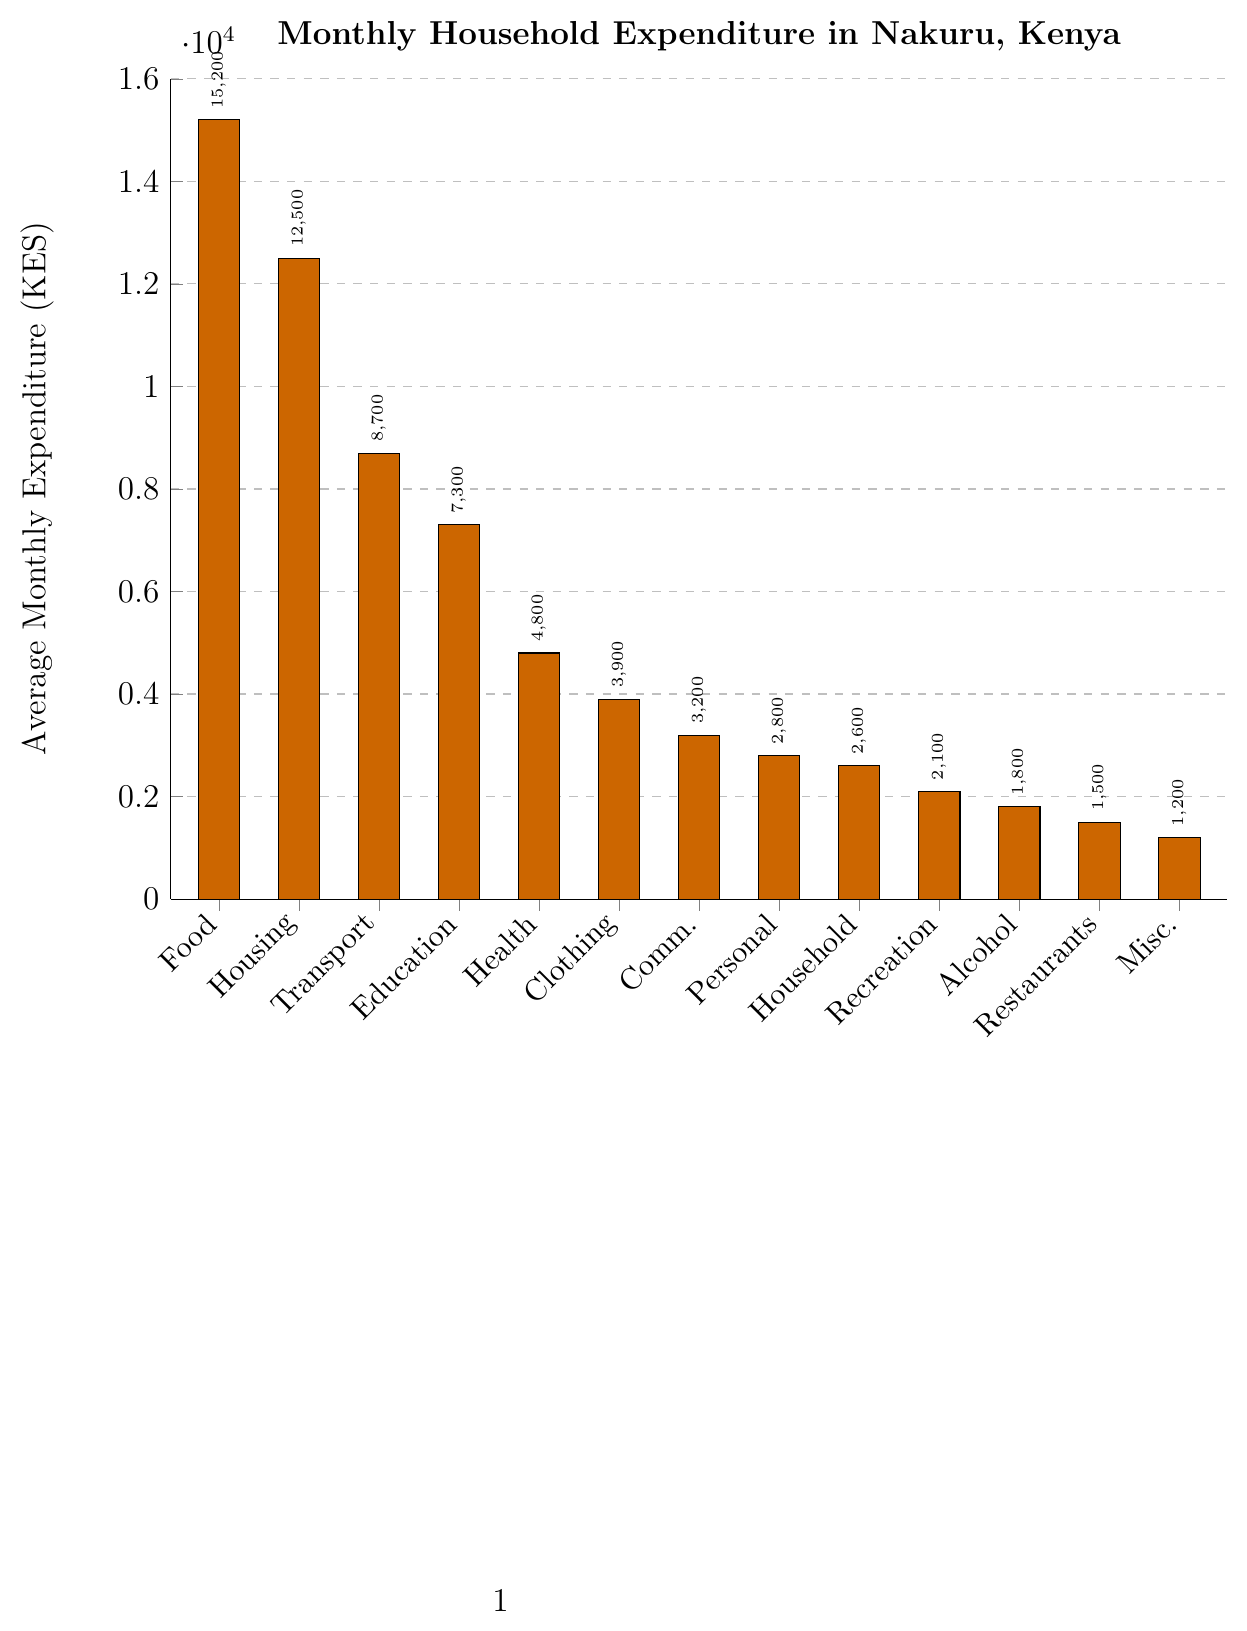Which category has the highest average monthly expenditure? The bar chart displays the height of each bar relative to the expenditure. The tallest bar, labeled "Food," represents the highest expenditure.
Answer: Food and non-alcoholic beverages Which category has the lowest average monthly expenditure? The shortest bar in the chart represents the lowest expenditure. The shortest bar is labeled "Misc."
Answer: Miscellaneous goods and services How much more do residents spend on Housing and utilities compared to Health? To find the difference in expenditures, subtract the expenditure for Health from the expenditure for Housing and utilities. That is 12500 - 4800.
Answer: 7700 KES What is the combined expenditure on Communication, Personal care, and Household goods and services? Add the expenditures for Communication, Personal care, and Household goods and services. That is 3200 + 2800 + 2600.
Answer: 8600 KES Which category, between Education and Transportation, has a higher average monthly expenditure? Compare the height of the bars labeled "Education" and "Transport." The bar for "Transport" is higher.
Answer: Transportation What is the difference between the highest and lowest average monthly expenditures? Subtract the lowest expenditure (Miscellaneous goods and services at 1200) from the highest expenditure (Food and non-alcoholic beverages at 15200).
Answer: 14000 KES What categories have an average monthly expenditure of less than 3000 KES? Identify all categories whose bars extend below the 3000 KES mark. The relevant bars are Personal care, Household goods and services, Recreation and culture, Alcoholic beverages and tobacco, Restaurants and hotels, and Miscellaneous goods and services.
Answer: Personal care, Household goods and services, Recreation and culture, Alcoholic beverages and tobacco, Restaurants and hotels, Miscellaneous goods and services Which two categories have the closest average monthly expenditures? Compare the heights of all the bars to find the pair with the smallest difference. Communication (3200) and Clothing and footwear (3900) have the closest expenditures, with a difference of 700.
Answer: Communication and Clothing and footwear What is the total average monthly expenditure on Food, Health, and Education combined? Add the expenditures for Food and non-alcoholic beverages, Health, and Education. That is 15200 + 4800 + 7300.
Answer: 27300 KES What percentage of the average monthly expenditure on Housing and utilities does Education represent? To find this, divide the expenditure on Education by the expenditure on Housing and utilities and multiply by 100. That is (7300 / 12500) * 100.
Answer: 58.4% 